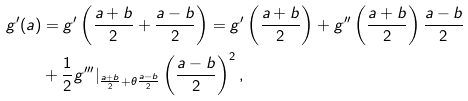<formula> <loc_0><loc_0><loc_500><loc_500>g ^ { \prime } ( a ) & = g ^ { \prime } \left ( \frac { a + b } { 2 } + \frac { a - b } { 2 } \right ) = g ^ { \prime } \left ( \frac { a + b } { 2 } \right ) + g ^ { \prime \prime } \left ( \frac { a + b } { 2 } \right ) \frac { a - b } { 2 } \\ & + \frac { 1 } { 2 } g ^ { \prime \prime \prime } | _ { \frac { a + b } { 2 } + \theta \frac { a - b } { 2 } } \left ( \frac { a - b } { 2 } \right ) ^ { 2 } ,</formula> 